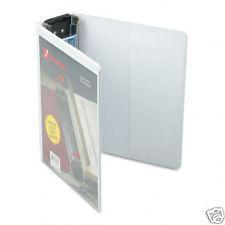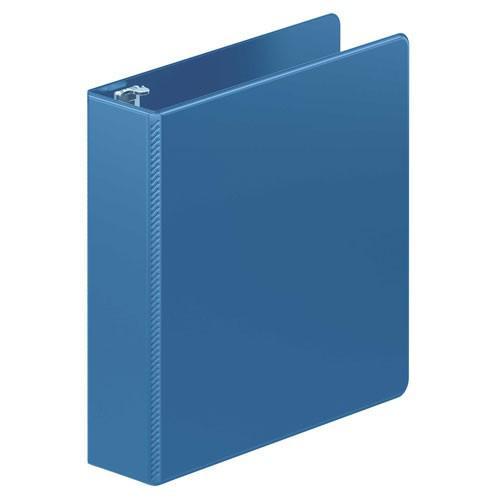The first image is the image on the left, the second image is the image on the right. Given the left and right images, does the statement "There are two binders in total." hold true? Answer yes or no. Yes. 